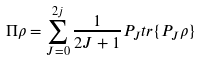Convert formula to latex. <formula><loc_0><loc_0><loc_500><loc_500>\Pi \rho = \sum _ { J = 0 } ^ { 2 j } \frac { 1 } { 2 J + 1 } P _ { J } { t r } \{ P _ { J } \rho \}</formula> 